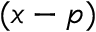Convert formula to latex. <formula><loc_0><loc_0><loc_500><loc_500>( x - p )</formula> 